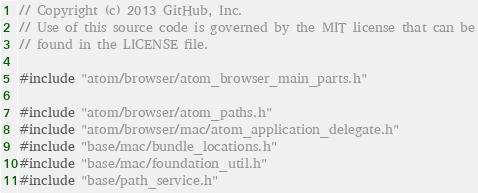<code> <loc_0><loc_0><loc_500><loc_500><_ObjectiveC_>// Copyright (c) 2013 GitHub, Inc.
// Use of this source code is governed by the MIT license that can be
// found in the LICENSE file.

#include "atom/browser/atom_browser_main_parts.h"

#include "atom/browser/atom_paths.h"
#include "atom/browser/mac/atom_application_delegate.h"
#include "base/mac/bundle_locations.h"
#include "base/mac/foundation_util.h"
#include "base/path_service.h"</code> 